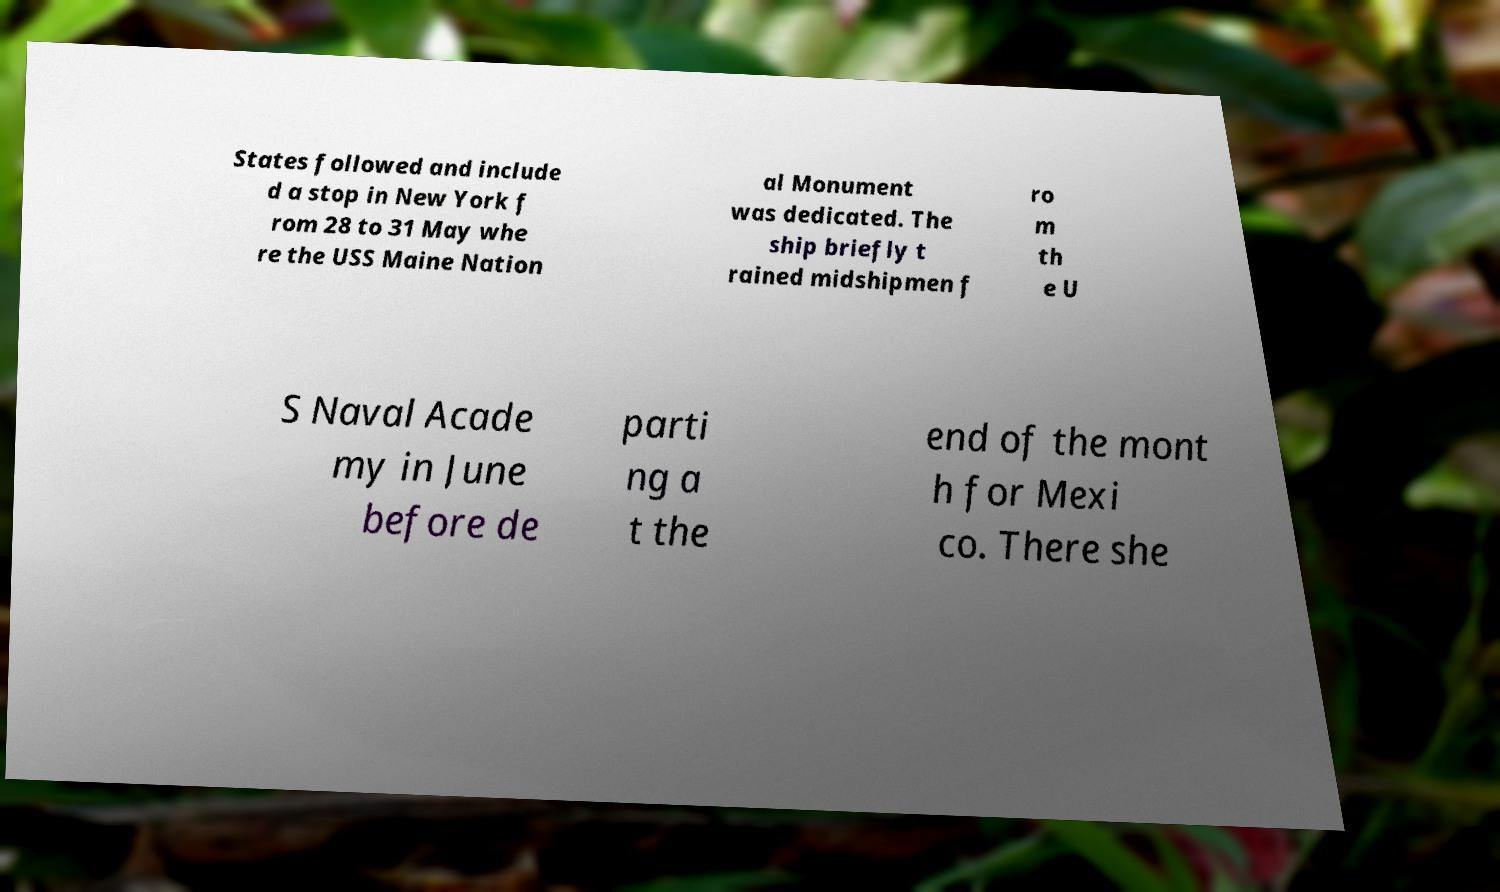For documentation purposes, I need the text within this image transcribed. Could you provide that? States followed and include d a stop in New York f rom 28 to 31 May whe re the USS Maine Nation al Monument was dedicated. The ship briefly t rained midshipmen f ro m th e U S Naval Acade my in June before de parti ng a t the end of the mont h for Mexi co. There she 